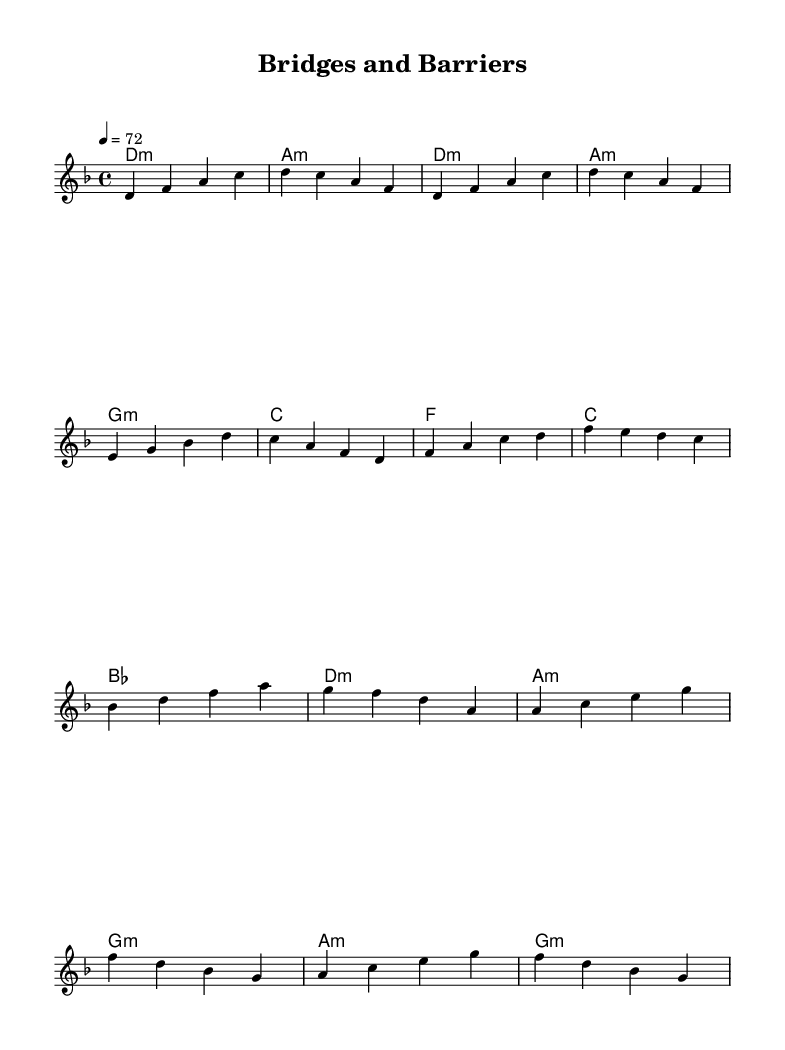What is the key signature of this music? The key signature is D minor, as indicated by the presence of one flat (B flat). In the key signature section of the sheet music, you can see the sharp and flat notes which help identify the key.
Answer: D minor What is the time signature of this music? The time signature is 4/4, which is indicated at the beginning of the sheet music. This means there are four beats in each measure and a quarter note gets one beat.
Answer: 4/4 What is the tempo marking of this piece? The tempo marking is 72 beats per minute, as specified on the sheet music. This indicates the speed at which the piece should be performed.
Answer: 72 How many measures are in the chorus? The chorus consists of four measures in total. You can count the measures indicated by vertical lines, specifically looking at the section labeled Chorus in the sheet music.
Answer: 4 What is the first chord of the verse? The first chord of the verse is D minor, which can be identified from the chord symbols written above the melody in the Verse section.
Answer: D minor Which section follows the chorus? The section that follows the chorus is the Bridge, clearly marked in the sheet music. This can be observed from the structure and the headings provided.
Answer: Bridge What emotional theme does this music explore? The music explores the emotional toll of conflict resolution, suggested by the introspective nature of the lyrics and the overall mood conveyed through the melodies and harmonies.
Answer: Emotional toll of conflict resolution 